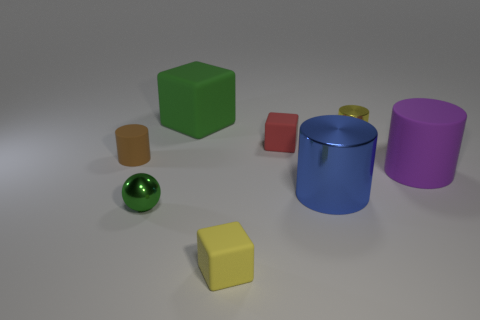What number of yellow blocks are in front of the matte thing in front of the purple matte cylinder?
Provide a succinct answer. 0. There is a rubber cylinder left of the yellow thing to the right of the tiny yellow matte thing; what color is it?
Your response must be concise. Brown. There is a object that is behind the purple cylinder and on the right side of the blue metallic cylinder; what is it made of?
Give a very brief answer. Metal. Are there any purple objects that have the same shape as the blue object?
Your response must be concise. Yes. Is the shape of the big rubber object that is left of the yellow metallic cylinder the same as  the blue metallic object?
Offer a terse response. No. What number of cylinders are both behind the big blue cylinder and on the left side of the yellow metallic cylinder?
Your answer should be very brief. 1. The small matte thing on the left side of the green sphere has what shape?
Ensure brevity in your answer.  Cylinder. How many big purple objects are the same material as the big blue cylinder?
Offer a terse response. 0. Is the shape of the small green object the same as the yellow thing that is behind the red cube?
Provide a succinct answer. No. Are there any green shiny objects that are in front of the large purple matte cylinder that is on the right side of the object that is in front of the sphere?
Your answer should be very brief. Yes. 